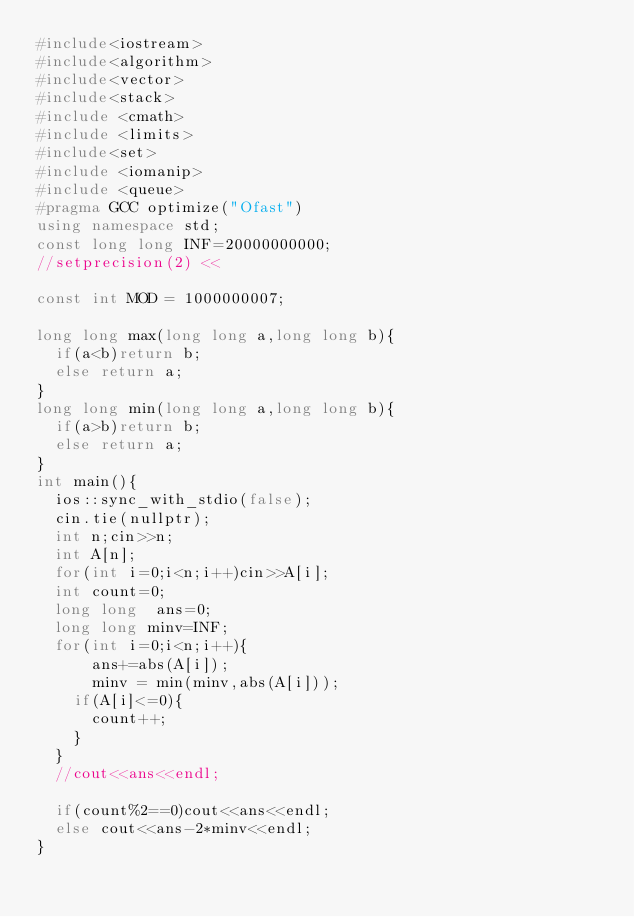<code> <loc_0><loc_0><loc_500><loc_500><_C++_>#include<iostream>
#include<algorithm>
#include<vector>
#include<stack>
#include <cmath>
#include <limits>
#include<set>
#include <iomanip>
#include <queue>
#pragma GCC optimize("Ofast")
using namespace std;
const long long INF=20000000000;
//setprecision(2) <<

const int MOD = 1000000007;

long long max(long long a,long long b){
	if(a<b)return b;
	else return a;	
}
long long min(long long a,long long b){
	if(a>b)return b;
	else return a;	
}
int main(){
	ios::sync_with_stdio(false);
	cin.tie(nullptr);
	int n;cin>>n;
	int A[n];
	for(int i=0;i<n;i++)cin>>A[i];
	int count=0;
	long long  ans=0;
	long long minv=INF; 
	for(int i=0;i<n;i++){
			ans+=abs(A[i]);
			minv = min(minv,abs(A[i]));
		if(A[i]<=0){
			count++;
		}
	}
	//cout<<ans<<endl;
	
	if(count%2==0)cout<<ans<<endl;
	else cout<<ans-2*minv<<endl;
}
	
</code> 